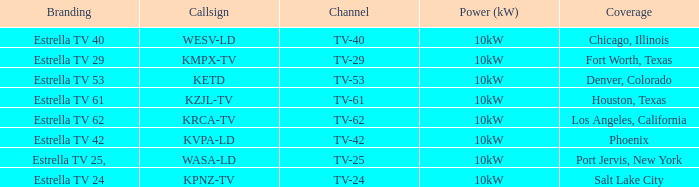Which city did kpnz-tv provide coverage for? Salt Lake City. 